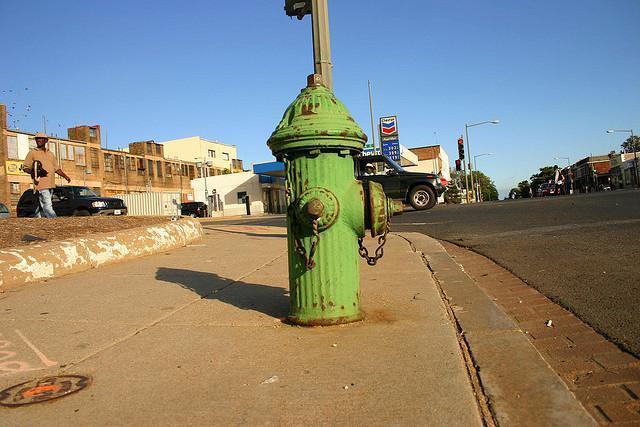How many trucks are visible?
Give a very brief answer. 2. 